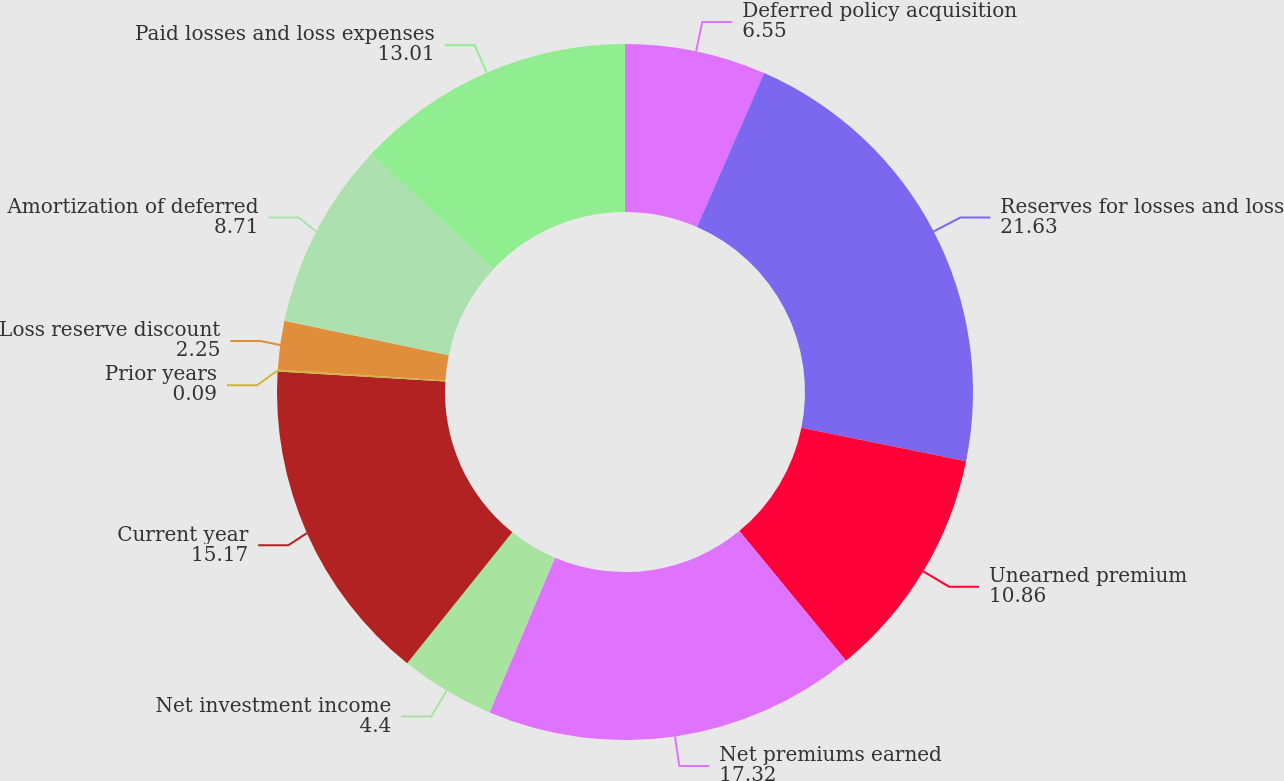Convert chart to OTSL. <chart><loc_0><loc_0><loc_500><loc_500><pie_chart><fcel>Deferred policy acquisition<fcel>Reserves for losses and loss<fcel>Unearned premium<fcel>Net premiums earned<fcel>Net investment income<fcel>Current year<fcel>Prior years<fcel>Loss reserve discount<fcel>Amortization of deferred<fcel>Paid losses and loss expenses<nl><fcel>6.55%<fcel>21.63%<fcel>10.86%<fcel>17.32%<fcel>4.4%<fcel>15.17%<fcel>0.09%<fcel>2.25%<fcel>8.71%<fcel>13.01%<nl></chart> 